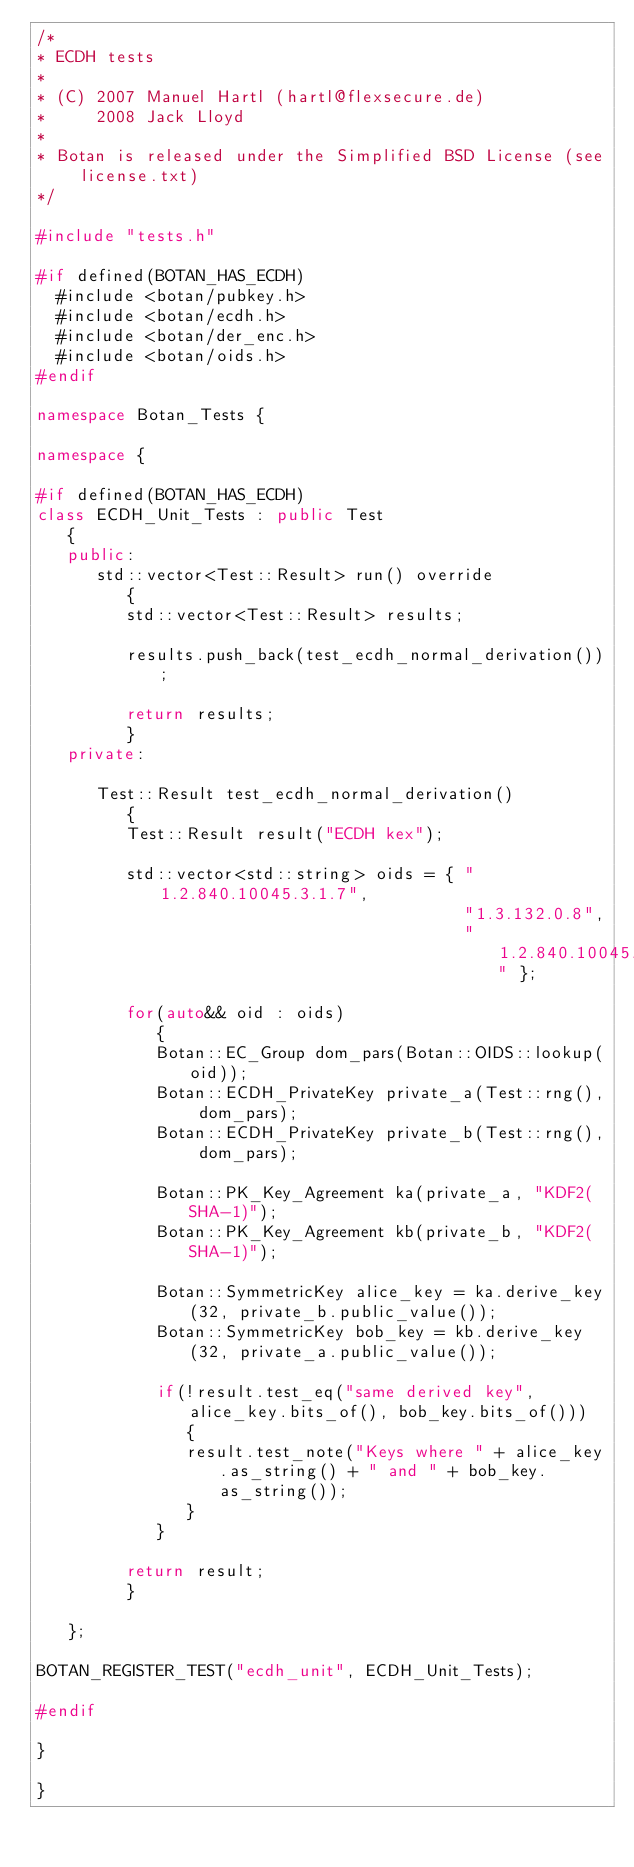Convert code to text. <code><loc_0><loc_0><loc_500><loc_500><_C++_>/*
* ECDH tests
*
* (C) 2007 Manuel Hartl (hartl@flexsecure.de)
*     2008 Jack Lloyd
*
* Botan is released under the Simplified BSD License (see license.txt)
*/

#include "tests.h"

#if defined(BOTAN_HAS_ECDH)
  #include <botan/pubkey.h>
  #include <botan/ecdh.h>
  #include <botan/der_enc.h>
  #include <botan/oids.h>
#endif

namespace Botan_Tests {

namespace {

#if defined(BOTAN_HAS_ECDH)
class ECDH_Unit_Tests : public Test
   {
   public:
      std::vector<Test::Result> run() override
         {
         std::vector<Test::Result> results;

         results.push_back(test_ecdh_normal_derivation());

         return results;
         }
   private:

      Test::Result test_ecdh_normal_derivation()
         {
         Test::Result result("ECDH kex");

         std::vector<std::string> oids = { "1.2.840.10045.3.1.7",
                                           "1.3.132.0.8",
                                           "1.2.840.10045.3.1.1" };

         for(auto&& oid : oids)
            {
            Botan::EC_Group dom_pars(Botan::OIDS::lookup(oid));
            Botan::ECDH_PrivateKey private_a(Test::rng(), dom_pars);
            Botan::ECDH_PrivateKey private_b(Test::rng(), dom_pars);

            Botan::PK_Key_Agreement ka(private_a, "KDF2(SHA-1)");
            Botan::PK_Key_Agreement kb(private_b, "KDF2(SHA-1)");

            Botan::SymmetricKey alice_key = ka.derive_key(32, private_b.public_value());
            Botan::SymmetricKey bob_key = kb.derive_key(32, private_a.public_value());

            if(!result.test_eq("same derived key", alice_key.bits_of(), bob_key.bits_of()))
               {
               result.test_note("Keys where " + alice_key.as_string() + " and " + bob_key.as_string());
               }
            }

         return result;
         }

   };

BOTAN_REGISTER_TEST("ecdh_unit", ECDH_Unit_Tests);

#endif

}

}
</code> 